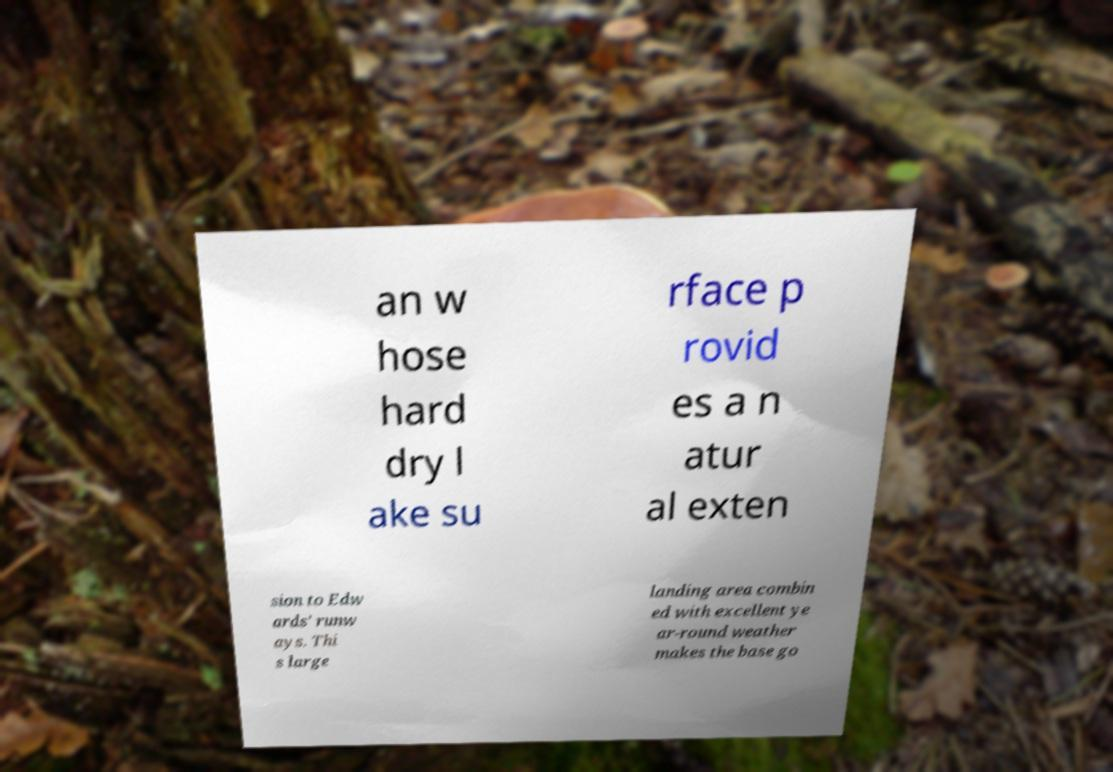Could you assist in decoding the text presented in this image and type it out clearly? an w hose hard dry l ake su rface p rovid es a n atur al exten sion to Edw ards' runw ays. Thi s large landing area combin ed with excellent ye ar-round weather makes the base go 